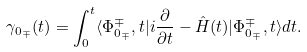<formula> <loc_0><loc_0><loc_500><loc_500>\gamma _ { 0 _ { \mp } } ( t ) = \int _ { 0 } ^ { t } \langle \Phi _ { 0 _ { \mp } } ^ { \mp } , t | i \frac { \partial } { \partial t } - \hat { H } ( t ) | \Phi _ { 0 _ { \mp } } ^ { \mp } , t \rangle d t .</formula> 